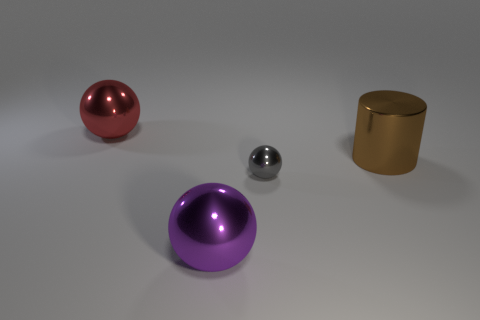Subtract all large metal spheres. How many spheres are left? 1 Add 3 red metallic spheres. How many objects exist? 7 Subtract all red spheres. How many spheres are left? 2 Subtract all spheres. How many objects are left? 1 Subtract 0 red cubes. How many objects are left? 4 Subtract all yellow spheres. Subtract all red cubes. How many spheres are left? 3 Subtract all large purple metallic spheres. Subtract all big brown metal objects. How many objects are left? 2 Add 4 big objects. How many big objects are left? 7 Add 2 big metal cylinders. How many big metal cylinders exist? 3 